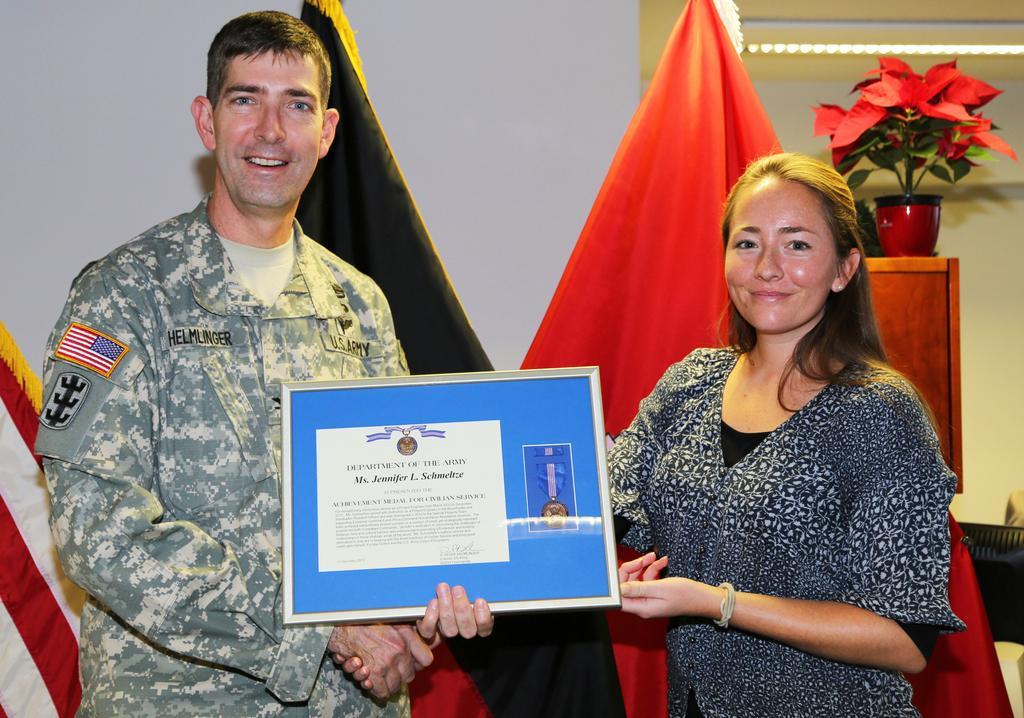Could you give a brief overview of what you see in this image? In this image I can see two persons holding an object. There is a plant in a flower pot. There is a wall and there is a cloth. 